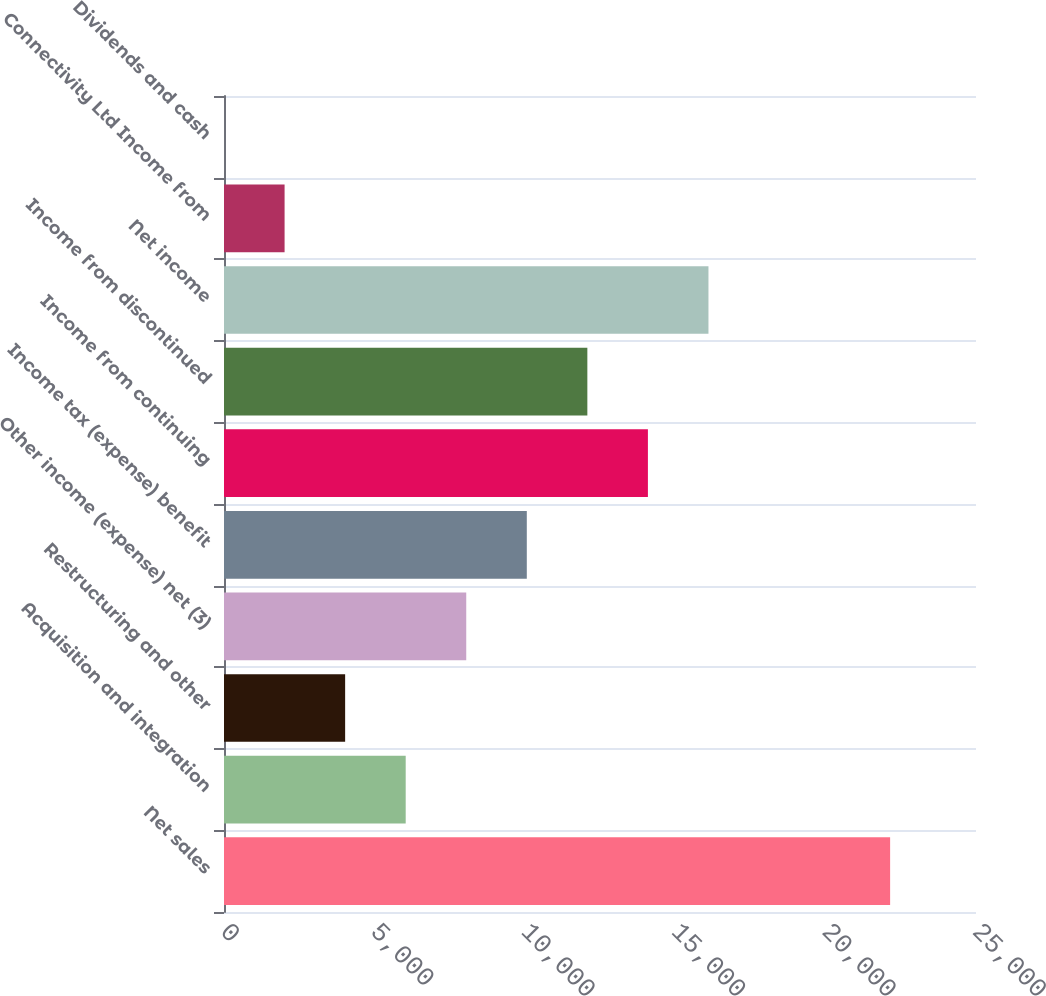Convert chart. <chart><loc_0><loc_0><loc_500><loc_500><bar_chart><fcel>Net sales<fcel>Acquisition and integration<fcel>Restructuring and other<fcel>Other income (expense) net (3)<fcel>Income tax (expense) benefit<fcel>Income from continuing<fcel>Income from discontinued<fcel>Net income<fcel>Connectivity Ltd Income from<fcel>Dividends and cash<nl><fcel>22145.1<fcel>6040.35<fcel>4027.26<fcel>8053.44<fcel>10066.5<fcel>14092.7<fcel>12079.6<fcel>16105.8<fcel>2014.17<fcel>1.08<nl></chart> 